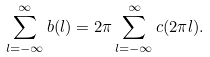Convert formula to latex. <formula><loc_0><loc_0><loc_500><loc_500>\sum _ { l = - \infty } ^ { \infty } b ( l ) = 2 \pi \sum _ { l = - \infty } ^ { \infty } c ( 2 \pi l ) .</formula> 